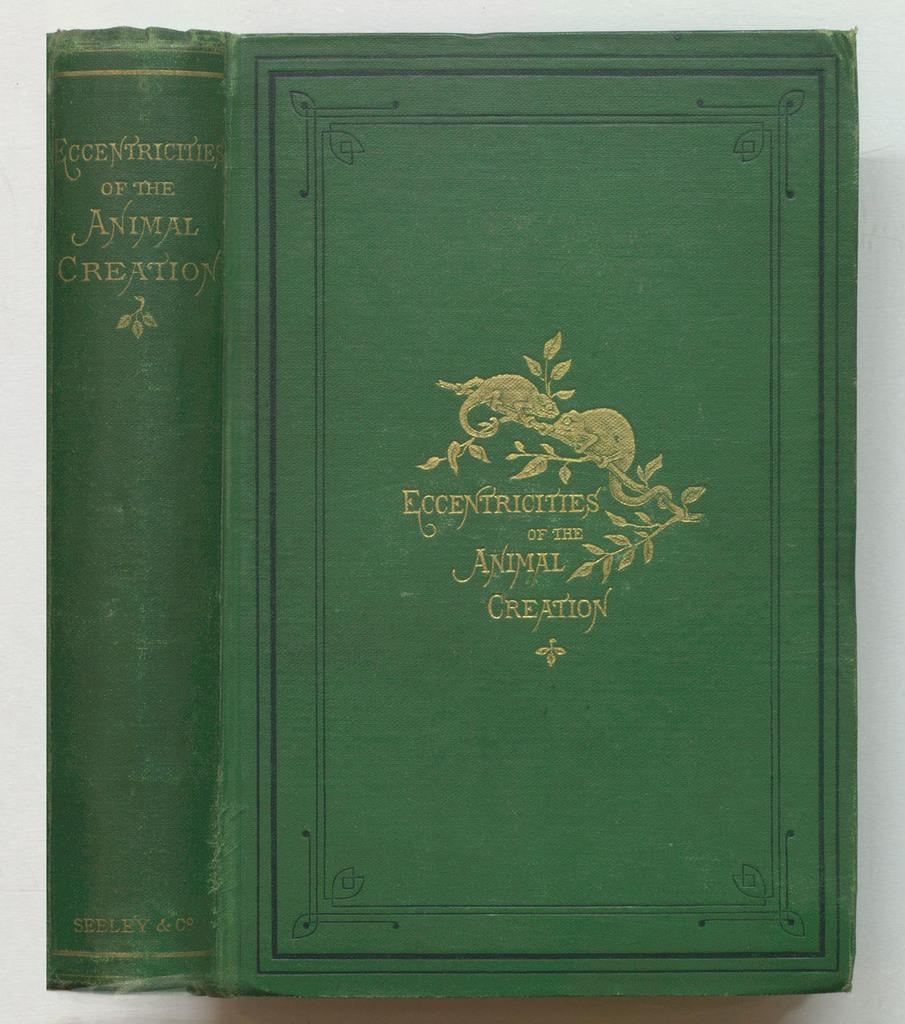<image>
Summarize the visual content of the image. A green book is titled Eccentricities  of the Animal Creation. 